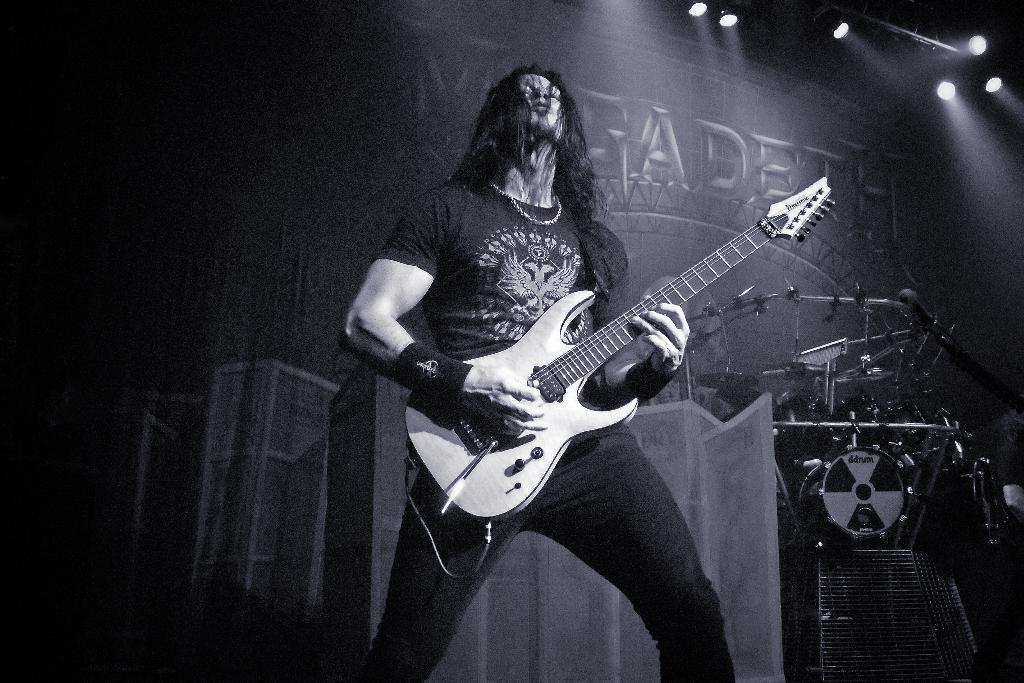How would you summarize this image in a sentence or two? In this image there is a man standing and playing a guitar and background there are drums. 